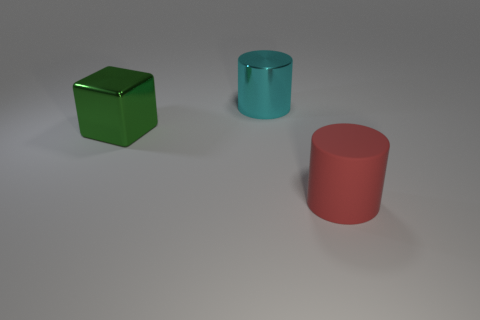Add 2 big cyan cubes. How many objects exist? 5 Subtract all cylinders. How many objects are left? 1 Add 1 red metallic objects. How many red metallic objects exist? 1 Subtract 0 yellow balls. How many objects are left? 3 Subtract all large blue objects. Subtract all rubber cylinders. How many objects are left? 2 Add 2 large blocks. How many large blocks are left? 3 